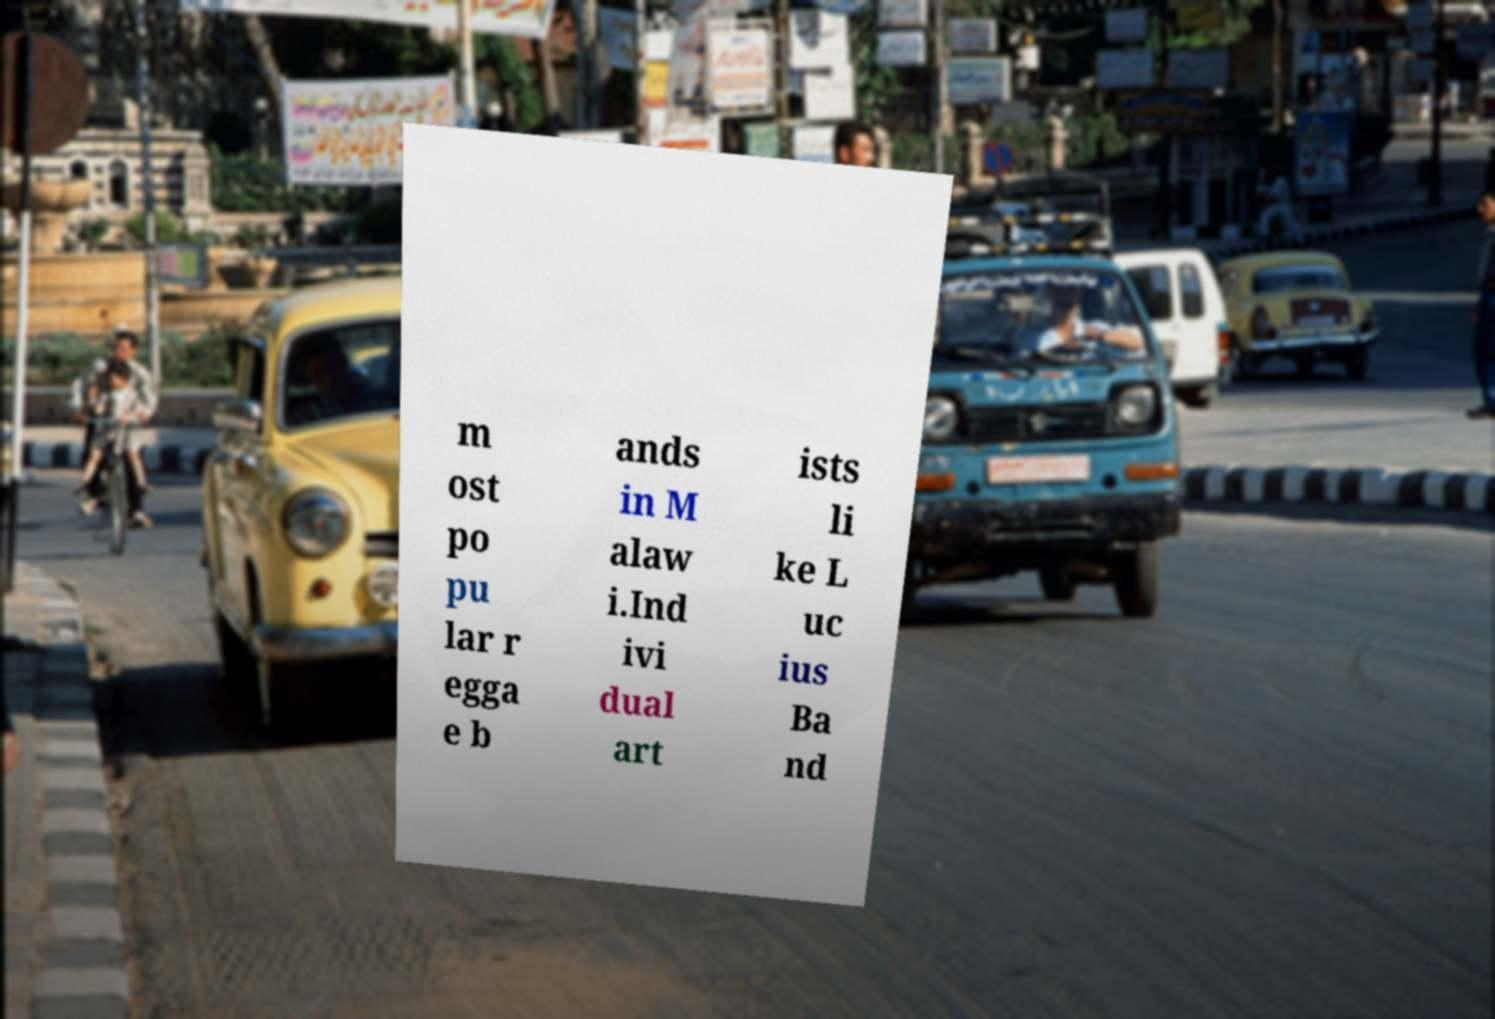What messages or text are displayed in this image? I need them in a readable, typed format. m ost po pu lar r egga e b ands in M alaw i.Ind ivi dual art ists li ke L uc ius Ba nd 